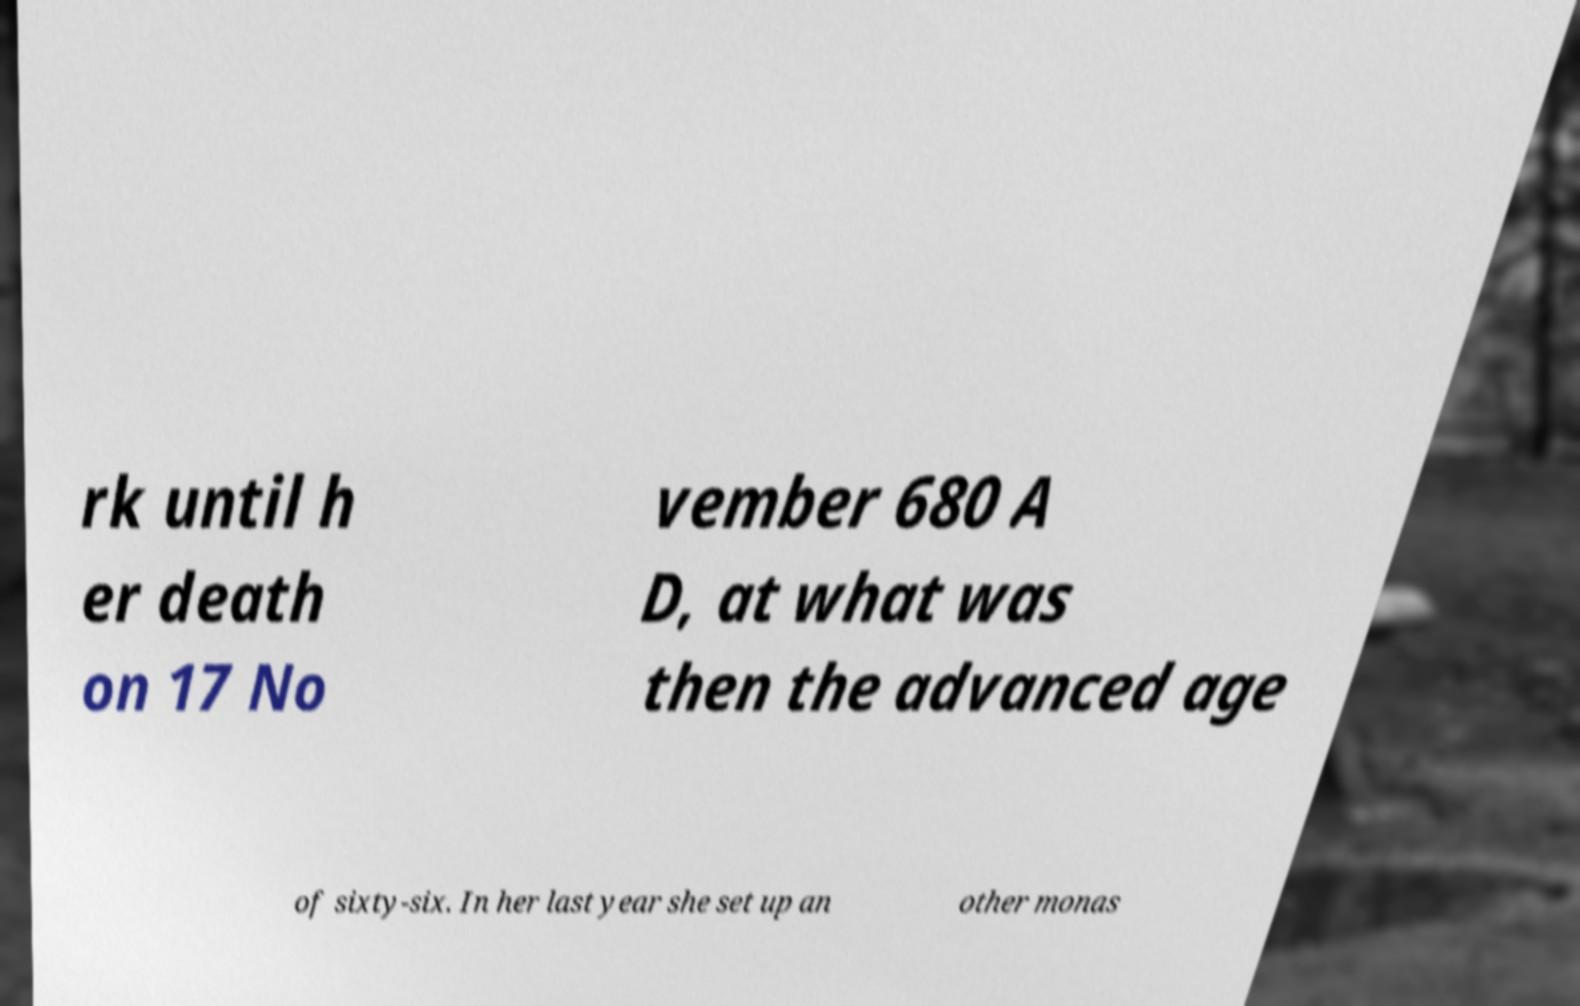Please read and relay the text visible in this image. What does it say? rk until h er death on 17 No vember 680 A D, at what was then the advanced age of sixty-six. In her last year she set up an other monas 